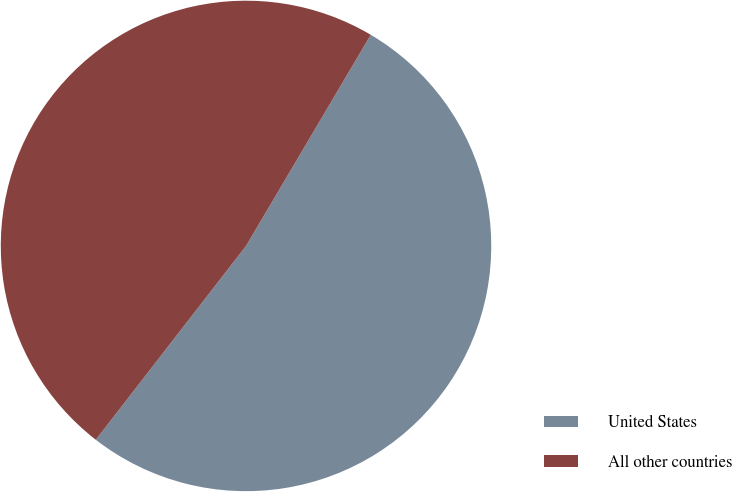<chart> <loc_0><loc_0><loc_500><loc_500><pie_chart><fcel>United States<fcel>All other countries<nl><fcel>52.0%<fcel>48.0%<nl></chart> 